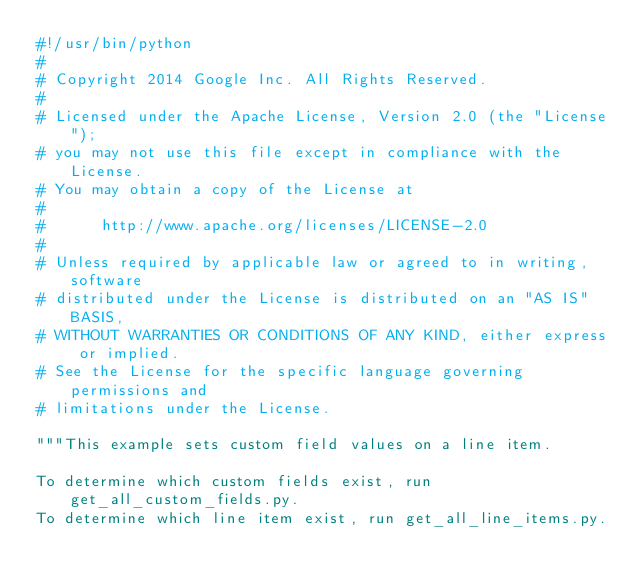Convert code to text. <code><loc_0><loc_0><loc_500><loc_500><_Python_>#!/usr/bin/python
#
# Copyright 2014 Google Inc. All Rights Reserved.
#
# Licensed under the Apache License, Version 2.0 (the "License");
# you may not use this file except in compliance with the License.
# You may obtain a copy of the License at
#
#      http://www.apache.org/licenses/LICENSE-2.0
#
# Unless required by applicable law or agreed to in writing, software
# distributed under the License is distributed on an "AS IS" BASIS,
# WITHOUT WARRANTIES OR CONDITIONS OF ANY KIND, either express or implied.
# See the License for the specific language governing permissions and
# limitations under the License.

"""This example sets custom field values on a line item.

To determine which custom fields exist, run get_all_custom_fields.py.
To determine which line item exist, run get_all_line_items.py.</code> 